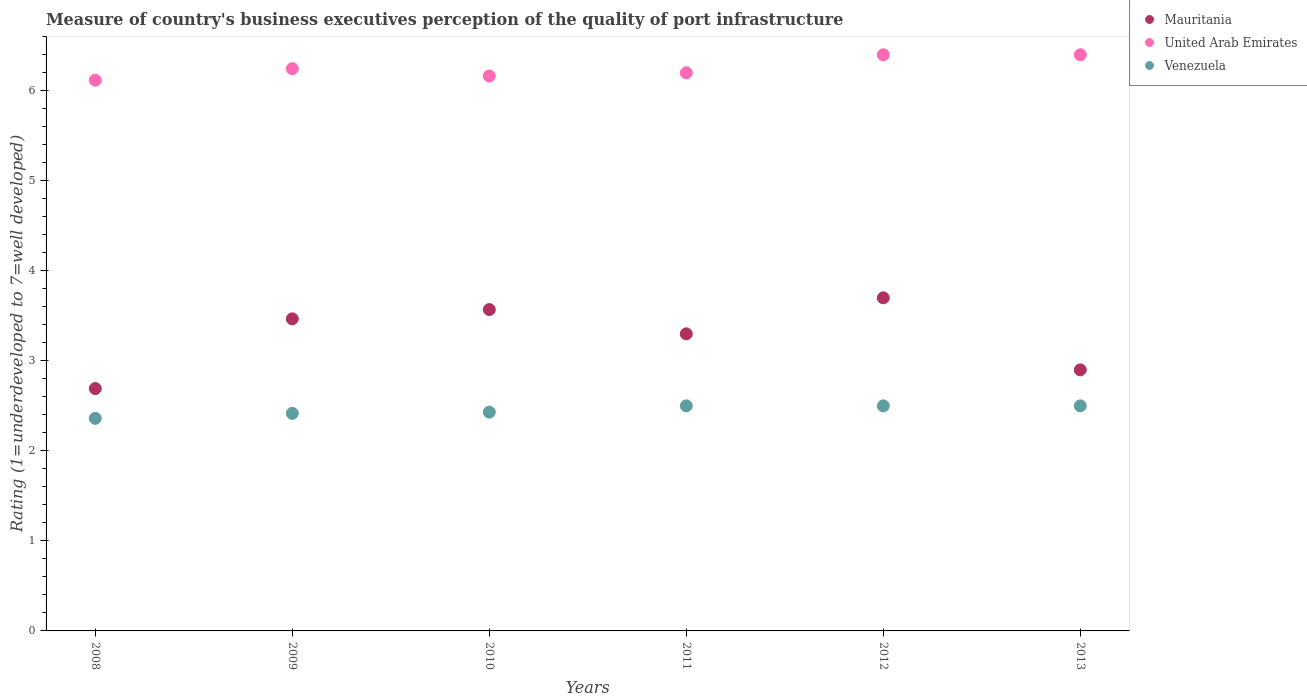Is the number of dotlines equal to the number of legend labels?
Provide a short and direct response. Yes. Across all years, what is the minimum ratings of the quality of port infrastructure in United Arab Emirates?
Keep it short and to the point. 6.12. In which year was the ratings of the quality of port infrastructure in Venezuela maximum?
Your answer should be compact. 2011. What is the total ratings of the quality of port infrastructure in Mauritania in the graph?
Give a very brief answer. 19.63. What is the difference between the ratings of the quality of port infrastructure in Mauritania in 2008 and that in 2012?
Ensure brevity in your answer.  -1.01. What is the difference between the ratings of the quality of port infrastructure in Venezuela in 2011 and the ratings of the quality of port infrastructure in Mauritania in 2012?
Give a very brief answer. -1.2. What is the average ratings of the quality of port infrastructure in Venezuela per year?
Your answer should be compact. 2.45. In how many years, is the ratings of the quality of port infrastructure in United Arab Emirates greater than 4.8?
Make the answer very short. 6. What is the ratio of the ratings of the quality of port infrastructure in United Arab Emirates in 2008 to that in 2009?
Your answer should be compact. 0.98. Is the difference between the ratings of the quality of port infrastructure in Mauritania in 2008 and 2013 greater than the difference between the ratings of the quality of port infrastructure in United Arab Emirates in 2008 and 2013?
Your response must be concise. Yes. What is the difference between the highest and the second highest ratings of the quality of port infrastructure in Mauritania?
Your answer should be compact. 0.13. What is the difference between the highest and the lowest ratings of the quality of port infrastructure in United Arab Emirates?
Offer a very short reply. 0.28. Is the sum of the ratings of the quality of port infrastructure in Mauritania in 2010 and 2011 greater than the maximum ratings of the quality of port infrastructure in United Arab Emirates across all years?
Ensure brevity in your answer.  Yes. Does the ratings of the quality of port infrastructure in Mauritania monotonically increase over the years?
Ensure brevity in your answer.  No. Is the ratings of the quality of port infrastructure in Mauritania strictly greater than the ratings of the quality of port infrastructure in Venezuela over the years?
Offer a terse response. Yes. How many dotlines are there?
Provide a succinct answer. 3. What is the difference between two consecutive major ticks on the Y-axis?
Your response must be concise. 1. Are the values on the major ticks of Y-axis written in scientific E-notation?
Provide a short and direct response. No. Does the graph contain grids?
Your answer should be very brief. No. Where does the legend appear in the graph?
Give a very brief answer. Top right. What is the title of the graph?
Offer a terse response. Measure of country's business executives perception of the quality of port infrastructure. What is the label or title of the Y-axis?
Make the answer very short. Rating (1=underdeveloped to 7=well developed). What is the Rating (1=underdeveloped to 7=well developed) in Mauritania in 2008?
Make the answer very short. 2.69. What is the Rating (1=underdeveloped to 7=well developed) in United Arab Emirates in 2008?
Keep it short and to the point. 6.12. What is the Rating (1=underdeveloped to 7=well developed) of Venezuela in 2008?
Make the answer very short. 2.36. What is the Rating (1=underdeveloped to 7=well developed) of Mauritania in 2009?
Your response must be concise. 3.47. What is the Rating (1=underdeveloped to 7=well developed) of United Arab Emirates in 2009?
Your answer should be compact. 6.24. What is the Rating (1=underdeveloped to 7=well developed) in Venezuela in 2009?
Offer a terse response. 2.42. What is the Rating (1=underdeveloped to 7=well developed) of Mauritania in 2010?
Your response must be concise. 3.57. What is the Rating (1=underdeveloped to 7=well developed) in United Arab Emirates in 2010?
Keep it short and to the point. 6.16. What is the Rating (1=underdeveloped to 7=well developed) in Venezuela in 2010?
Your response must be concise. 2.43. What is the Rating (1=underdeveloped to 7=well developed) of Mauritania in 2011?
Your answer should be very brief. 3.3. Across all years, what is the maximum Rating (1=underdeveloped to 7=well developed) in Mauritania?
Your answer should be very brief. 3.7. Across all years, what is the maximum Rating (1=underdeveloped to 7=well developed) in United Arab Emirates?
Keep it short and to the point. 6.4. Across all years, what is the minimum Rating (1=underdeveloped to 7=well developed) in Mauritania?
Provide a succinct answer. 2.69. Across all years, what is the minimum Rating (1=underdeveloped to 7=well developed) of United Arab Emirates?
Offer a terse response. 6.12. Across all years, what is the minimum Rating (1=underdeveloped to 7=well developed) of Venezuela?
Your response must be concise. 2.36. What is the total Rating (1=underdeveloped to 7=well developed) in Mauritania in the graph?
Ensure brevity in your answer.  19.63. What is the total Rating (1=underdeveloped to 7=well developed) in United Arab Emirates in the graph?
Your answer should be very brief. 37.53. What is the total Rating (1=underdeveloped to 7=well developed) in Venezuela in the graph?
Provide a short and direct response. 14.71. What is the difference between the Rating (1=underdeveloped to 7=well developed) of Mauritania in 2008 and that in 2009?
Keep it short and to the point. -0.77. What is the difference between the Rating (1=underdeveloped to 7=well developed) of United Arab Emirates in 2008 and that in 2009?
Offer a very short reply. -0.13. What is the difference between the Rating (1=underdeveloped to 7=well developed) in Venezuela in 2008 and that in 2009?
Your response must be concise. -0.06. What is the difference between the Rating (1=underdeveloped to 7=well developed) of Mauritania in 2008 and that in 2010?
Your answer should be very brief. -0.88. What is the difference between the Rating (1=underdeveloped to 7=well developed) of United Arab Emirates in 2008 and that in 2010?
Offer a terse response. -0.05. What is the difference between the Rating (1=underdeveloped to 7=well developed) in Venezuela in 2008 and that in 2010?
Provide a short and direct response. -0.07. What is the difference between the Rating (1=underdeveloped to 7=well developed) in Mauritania in 2008 and that in 2011?
Your response must be concise. -0.61. What is the difference between the Rating (1=underdeveloped to 7=well developed) in United Arab Emirates in 2008 and that in 2011?
Your answer should be compact. -0.08. What is the difference between the Rating (1=underdeveloped to 7=well developed) in Venezuela in 2008 and that in 2011?
Your response must be concise. -0.14. What is the difference between the Rating (1=underdeveloped to 7=well developed) of Mauritania in 2008 and that in 2012?
Ensure brevity in your answer.  -1.01. What is the difference between the Rating (1=underdeveloped to 7=well developed) in United Arab Emirates in 2008 and that in 2012?
Make the answer very short. -0.28. What is the difference between the Rating (1=underdeveloped to 7=well developed) of Venezuela in 2008 and that in 2012?
Make the answer very short. -0.14. What is the difference between the Rating (1=underdeveloped to 7=well developed) of Mauritania in 2008 and that in 2013?
Your answer should be compact. -0.21. What is the difference between the Rating (1=underdeveloped to 7=well developed) of United Arab Emirates in 2008 and that in 2013?
Keep it short and to the point. -0.28. What is the difference between the Rating (1=underdeveloped to 7=well developed) in Venezuela in 2008 and that in 2013?
Provide a succinct answer. -0.14. What is the difference between the Rating (1=underdeveloped to 7=well developed) of Mauritania in 2009 and that in 2010?
Provide a short and direct response. -0.1. What is the difference between the Rating (1=underdeveloped to 7=well developed) in United Arab Emirates in 2009 and that in 2010?
Your response must be concise. 0.08. What is the difference between the Rating (1=underdeveloped to 7=well developed) in Venezuela in 2009 and that in 2010?
Your response must be concise. -0.01. What is the difference between the Rating (1=underdeveloped to 7=well developed) in Mauritania in 2009 and that in 2011?
Offer a very short reply. 0.17. What is the difference between the Rating (1=underdeveloped to 7=well developed) in United Arab Emirates in 2009 and that in 2011?
Your answer should be very brief. 0.04. What is the difference between the Rating (1=underdeveloped to 7=well developed) of Venezuela in 2009 and that in 2011?
Make the answer very short. -0.08. What is the difference between the Rating (1=underdeveloped to 7=well developed) in Mauritania in 2009 and that in 2012?
Your answer should be very brief. -0.23. What is the difference between the Rating (1=underdeveloped to 7=well developed) in United Arab Emirates in 2009 and that in 2012?
Provide a succinct answer. -0.15. What is the difference between the Rating (1=underdeveloped to 7=well developed) in Venezuela in 2009 and that in 2012?
Your response must be concise. -0.08. What is the difference between the Rating (1=underdeveloped to 7=well developed) of Mauritania in 2009 and that in 2013?
Provide a short and direct response. 0.57. What is the difference between the Rating (1=underdeveloped to 7=well developed) of United Arab Emirates in 2009 and that in 2013?
Your answer should be compact. -0.15. What is the difference between the Rating (1=underdeveloped to 7=well developed) of Venezuela in 2009 and that in 2013?
Make the answer very short. -0.08. What is the difference between the Rating (1=underdeveloped to 7=well developed) in Mauritania in 2010 and that in 2011?
Your response must be concise. 0.27. What is the difference between the Rating (1=underdeveloped to 7=well developed) in United Arab Emirates in 2010 and that in 2011?
Offer a terse response. -0.04. What is the difference between the Rating (1=underdeveloped to 7=well developed) in Venezuela in 2010 and that in 2011?
Keep it short and to the point. -0.07. What is the difference between the Rating (1=underdeveloped to 7=well developed) in Mauritania in 2010 and that in 2012?
Make the answer very short. -0.13. What is the difference between the Rating (1=underdeveloped to 7=well developed) in United Arab Emirates in 2010 and that in 2012?
Give a very brief answer. -0.24. What is the difference between the Rating (1=underdeveloped to 7=well developed) of Venezuela in 2010 and that in 2012?
Keep it short and to the point. -0.07. What is the difference between the Rating (1=underdeveloped to 7=well developed) in Mauritania in 2010 and that in 2013?
Provide a succinct answer. 0.67. What is the difference between the Rating (1=underdeveloped to 7=well developed) in United Arab Emirates in 2010 and that in 2013?
Make the answer very short. -0.24. What is the difference between the Rating (1=underdeveloped to 7=well developed) of Venezuela in 2010 and that in 2013?
Your answer should be compact. -0.07. What is the difference between the Rating (1=underdeveloped to 7=well developed) of Mauritania in 2011 and that in 2012?
Your answer should be compact. -0.4. What is the difference between the Rating (1=underdeveloped to 7=well developed) of United Arab Emirates in 2011 and that in 2013?
Offer a very short reply. -0.2. What is the difference between the Rating (1=underdeveloped to 7=well developed) of Mauritania in 2012 and that in 2013?
Your response must be concise. 0.8. What is the difference between the Rating (1=underdeveloped to 7=well developed) of Venezuela in 2012 and that in 2013?
Your answer should be compact. 0. What is the difference between the Rating (1=underdeveloped to 7=well developed) in Mauritania in 2008 and the Rating (1=underdeveloped to 7=well developed) in United Arab Emirates in 2009?
Provide a succinct answer. -3.55. What is the difference between the Rating (1=underdeveloped to 7=well developed) in Mauritania in 2008 and the Rating (1=underdeveloped to 7=well developed) in Venezuela in 2009?
Make the answer very short. 0.28. What is the difference between the Rating (1=underdeveloped to 7=well developed) in United Arab Emirates in 2008 and the Rating (1=underdeveloped to 7=well developed) in Venezuela in 2009?
Offer a very short reply. 3.7. What is the difference between the Rating (1=underdeveloped to 7=well developed) of Mauritania in 2008 and the Rating (1=underdeveloped to 7=well developed) of United Arab Emirates in 2010?
Keep it short and to the point. -3.47. What is the difference between the Rating (1=underdeveloped to 7=well developed) of Mauritania in 2008 and the Rating (1=underdeveloped to 7=well developed) of Venezuela in 2010?
Offer a very short reply. 0.26. What is the difference between the Rating (1=underdeveloped to 7=well developed) of United Arab Emirates in 2008 and the Rating (1=underdeveloped to 7=well developed) of Venezuela in 2010?
Offer a terse response. 3.69. What is the difference between the Rating (1=underdeveloped to 7=well developed) in Mauritania in 2008 and the Rating (1=underdeveloped to 7=well developed) in United Arab Emirates in 2011?
Your answer should be compact. -3.51. What is the difference between the Rating (1=underdeveloped to 7=well developed) in Mauritania in 2008 and the Rating (1=underdeveloped to 7=well developed) in Venezuela in 2011?
Provide a short and direct response. 0.19. What is the difference between the Rating (1=underdeveloped to 7=well developed) of United Arab Emirates in 2008 and the Rating (1=underdeveloped to 7=well developed) of Venezuela in 2011?
Give a very brief answer. 3.62. What is the difference between the Rating (1=underdeveloped to 7=well developed) of Mauritania in 2008 and the Rating (1=underdeveloped to 7=well developed) of United Arab Emirates in 2012?
Your answer should be very brief. -3.71. What is the difference between the Rating (1=underdeveloped to 7=well developed) in Mauritania in 2008 and the Rating (1=underdeveloped to 7=well developed) in Venezuela in 2012?
Keep it short and to the point. 0.19. What is the difference between the Rating (1=underdeveloped to 7=well developed) of United Arab Emirates in 2008 and the Rating (1=underdeveloped to 7=well developed) of Venezuela in 2012?
Your answer should be compact. 3.62. What is the difference between the Rating (1=underdeveloped to 7=well developed) of Mauritania in 2008 and the Rating (1=underdeveloped to 7=well developed) of United Arab Emirates in 2013?
Provide a succinct answer. -3.71. What is the difference between the Rating (1=underdeveloped to 7=well developed) of Mauritania in 2008 and the Rating (1=underdeveloped to 7=well developed) of Venezuela in 2013?
Offer a very short reply. 0.19. What is the difference between the Rating (1=underdeveloped to 7=well developed) of United Arab Emirates in 2008 and the Rating (1=underdeveloped to 7=well developed) of Venezuela in 2013?
Provide a succinct answer. 3.62. What is the difference between the Rating (1=underdeveloped to 7=well developed) of Mauritania in 2009 and the Rating (1=underdeveloped to 7=well developed) of United Arab Emirates in 2010?
Make the answer very short. -2.7. What is the difference between the Rating (1=underdeveloped to 7=well developed) of Mauritania in 2009 and the Rating (1=underdeveloped to 7=well developed) of Venezuela in 2010?
Your response must be concise. 1.04. What is the difference between the Rating (1=underdeveloped to 7=well developed) of United Arab Emirates in 2009 and the Rating (1=underdeveloped to 7=well developed) of Venezuela in 2010?
Offer a terse response. 3.81. What is the difference between the Rating (1=underdeveloped to 7=well developed) in Mauritania in 2009 and the Rating (1=underdeveloped to 7=well developed) in United Arab Emirates in 2011?
Provide a succinct answer. -2.73. What is the difference between the Rating (1=underdeveloped to 7=well developed) of Mauritania in 2009 and the Rating (1=underdeveloped to 7=well developed) of Venezuela in 2011?
Your response must be concise. 0.97. What is the difference between the Rating (1=underdeveloped to 7=well developed) of United Arab Emirates in 2009 and the Rating (1=underdeveloped to 7=well developed) of Venezuela in 2011?
Offer a very short reply. 3.75. What is the difference between the Rating (1=underdeveloped to 7=well developed) in Mauritania in 2009 and the Rating (1=underdeveloped to 7=well developed) in United Arab Emirates in 2012?
Make the answer very short. -2.93. What is the difference between the Rating (1=underdeveloped to 7=well developed) of Mauritania in 2009 and the Rating (1=underdeveloped to 7=well developed) of Venezuela in 2012?
Make the answer very short. 0.97. What is the difference between the Rating (1=underdeveloped to 7=well developed) in United Arab Emirates in 2009 and the Rating (1=underdeveloped to 7=well developed) in Venezuela in 2012?
Offer a very short reply. 3.75. What is the difference between the Rating (1=underdeveloped to 7=well developed) in Mauritania in 2009 and the Rating (1=underdeveloped to 7=well developed) in United Arab Emirates in 2013?
Your answer should be compact. -2.93. What is the difference between the Rating (1=underdeveloped to 7=well developed) in Mauritania in 2009 and the Rating (1=underdeveloped to 7=well developed) in Venezuela in 2013?
Your answer should be compact. 0.97. What is the difference between the Rating (1=underdeveloped to 7=well developed) of United Arab Emirates in 2009 and the Rating (1=underdeveloped to 7=well developed) of Venezuela in 2013?
Provide a short and direct response. 3.75. What is the difference between the Rating (1=underdeveloped to 7=well developed) in Mauritania in 2010 and the Rating (1=underdeveloped to 7=well developed) in United Arab Emirates in 2011?
Ensure brevity in your answer.  -2.63. What is the difference between the Rating (1=underdeveloped to 7=well developed) in Mauritania in 2010 and the Rating (1=underdeveloped to 7=well developed) in Venezuela in 2011?
Offer a very short reply. 1.07. What is the difference between the Rating (1=underdeveloped to 7=well developed) in United Arab Emirates in 2010 and the Rating (1=underdeveloped to 7=well developed) in Venezuela in 2011?
Provide a short and direct response. 3.66. What is the difference between the Rating (1=underdeveloped to 7=well developed) of Mauritania in 2010 and the Rating (1=underdeveloped to 7=well developed) of United Arab Emirates in 2012?
Make the answer very short. -2.83. What is the difference between the Rating (1=underdeveloped to 7=well developed) in Mauritania in 2010 and the Rating (1=underdeveloped to 7=well developed) in Venezuela in 2012?
Ensure brevity in your answer.  1.07. What is the difference between the Rating (1=underdeveloped to 7=well developed) of United Arab Emirates in 2010 and the Rating (1=underdeveloped to 7=well developed) of Venezuela in 2012?
Your answer should be compact. 3.66. What is the difference between the Rating (1=underdeveloped to 7=well developed) in Mauritania in 2010 and the Rating (1=underdeveloped to 7=well developed) in United Arab Emirates in 2013?
Offer a very short reply. -2.83. What is the difference between the Rating (1=underdeveloped to 7=well developed) in Mauritania in 2010 and the Rating (1=underdeveloped to 7=well developed) in Venezuela in 2013?
Make the answer very short. 1.07. What is the difference between the Rating (1=underdeveloped to 7=well developed) of United Arab Emirates in 2010 and the Rating (1=underdeveloped to 7=well developed) of Venezuela in 2013?
Provide a succinct answer. 3.66. What is the difference between the Rating (1=underdeveloped to 7=well developed) of Mauritania in 2011 and the Rating (1=underdeveloped to 7=well developed) of United Arab Emirates in 2013?
Offer a very short reply. -3.1. What is the difference between the Rating (1=underdeveloped to 7=well developed) of United Arab Emirates in 2011 and the Rating (1=underdeveloped to 7=well developed) of Venezuela in 2013?
Offer a very short reply. 3.7. What is the average Rating (1=underdeveloped to 7=well developed) in Mauritania per year?
Make the answer very short. 3.27. What is the average Rating (1=underdeveloped to 7=well developed) of United Arab Emirates per year?
Make the answer very short. 6.25. What is the average Rating (1=underdeveloped to 7=well developed) in Venezuela per year?
Keep it short and to the point. 2.45. In the year 2008, what is the difference between the Rating (1=underdeveloped to 7=well developed) of Mauritania and Rating (1=underdeveloped to 7=well developed) of United Arab Emirates?
Give a very brief answer. -3.43. In the year 2008, what is the difference between the Rating (1=underdeveloped to 7=well developed) in Mauritania and Rating (1=underdeveloped to 7=well developed) in Venezuela?
Your response must be concise. 0.33. In the year 2008, what is the difference between the Rating (1=underdeveloped to 7=well developed) of United Arab Emirates and Rating (1=underdeveloped to 7=well developed) of Venezuela?
Make the answer very short. 3.76. In the year 2009, what is the difference between the Rating (1=underdeveloped to 7=well developed) of Mauritania and Rating (1=underdeveloped to 7=well developed) of United Arab Emirates?
Your response must be concise. -2.78. In the year 2009, what is the difference between the Rating (1=underdeveloped to 7=well developed) in Mauritania and Rating (1=underdeveloped to 7=well developed) in Venezuela?
Your answer should be very brief. 1.05. In the year 2009, what is the difference between the Rating (1=underdeveloped to 7=well developed) in United Arab Emirates and Rating (1=underdeveloped to 7=well developed) in Venezuela?
Keep it short and to the point. 3.83. In the year 2010, what is the difference between the Rating (1=underdeveloped to 7=well developed) of Mauritania and Rating (1=underdeveloped to 7=well developed) of United Arab Emirates?
Offer a very short reply. -2.59. In the year 2010, what is the difference between the Rating (1=underdeveloped to 7=well developed) in Mauritania and Rating (1=underdeveloped to 7=well developed) in Venezuela?
Keep it short and to the point. 1.14. In the year 2010, what is the difference between the Rating (1=underdeveloped to 7=well developed) in United Arab Emirates and Rating (1=underdeveloped to 7=well developed) in Venezuela?
Keep it short and to the point. 3.73. In the year 2011, what is the difference between the Rating (1=underdeveloped to 7=well developed) of Mauritania and Rating (1=underdeveloped to 7=well developed) of United Arab Emirates?
Make the answer very short. -2.9. In the year 2012, what is the difference between the Rating (1=underdeveloped to 7=well developed) in Mauritania and Rating (1=underdeveloped to 7=well developed) in United Arab Emirates?
Your answer should be compact. -2.7. In the year 2012, what is the difference between the Rating (1=underdeveloped to 7=well developed) in United Arab Emirates and Rating (1=underdeveloped to 7=well developed) in Venezuela?
Keep it short and to the point. 3.9. In the year 2013, what is the difference between the Rating (1=underdeveloped to 7=well developed) of Mauritania and Rating (1=underdeveloped to 7=well developed) of United Arab Emirates?
Provide a succinct answer. -3.5. In the year 2013, what is the difference between the Rating (1=underdeveloped to 7=well developed) in Mauritania and Rating (1=underdeveloped to 7=well developed) in Venezuela?
Offer a terse response. 0.4. In the year 2013, what is the difference between the Rating (1=underdeveloped to 7=well developed) of United Arab Emirates and Rating (1=underdeveloped to 7=well developed) of Venezuela?
Keep it short and to the point. 3.9. What is the ratio of the Rating (1=underdeveloped to 7=well developed) in Mauritania in 2008 to that in 2009?
Provide a succinct answer. 0.78. What is the ratio of the Rating (1=underdeveloped to 7=well developed) of United Arab Emirates in 2008 to that in 2009?
Your answer should be compact. 0.98. What is the ratio of the Rating (1=underdeveloped to 7=well developed) of Venezuela in 2008 to that in 2009?
Offer a very short reply. 0.98. What is the ratio of the Rating (1=underdeveloped to 7=well developed) of Mauritania in 2008 to that in 2010?
Ensure brevity in your answer.  0.75. What is the ratio of the Rating (1=underdeveloped to 7=well developed) in United Arab Emirates in 2008 to that in 2010?
Ensure brevity in your answer.  0.99. What is the ratio of the Rating (1=underdeveloped to 7=well developed) in Venezuela in 2008 to that in 2010?
Keep it short and to the point. 0.97. What is the ratio of the Rating (1=underdeveloped to 7=well developed) in Mauritania in 2008 to that in 2011?
Keep it short and to the point. 0.82. What is the ratio of the Rating (1=underdeveloped to 7=well developed) of United Arab Emirates in 2008 to that in 2011?
Your response must be concise. 0.99. What is the ratio of the Rating (1=underdeveloped to 7=well developed) of Venezuela in 2008 to that in 2011?
Offer a terse response. 0.94. What is the ratio of the Rating (1=underdeveloped to 7=well developed) of Mauritania in 2008 to that in 2012?
Your answer should be compact. 0.73. What is the ratio of the Rating (1=underdeveloped to 7=well developed) of United Arab Emirates in 2008 to that in 2012?
Ensure brevity in your answer.  0.96. What is the ratio of the Rating (1=underdeveloped to 7=well developed) in Venezuela in 2008 to that in 2012?
Offer a very short reply. 0.94. What is the ratio of the Rating (1=underdeveloped to 7=well developed) of Mauritania in 2008 to that in 2013?
Provide a short and direct response. 0.93. What is the ratio of the Rating (1=underdeveloped to 7=well developed) of United Arab Emirates in 2008 to that in 2013?
Provide a succinct answer. 0.96. What is the ratio of the Rating (1=underdeveloped to 7=well developed) in Mauritania in 2009 to that in 2010?
Ensure brevity in your answer.  0.97. What is the ratio of the Rating (1=underdeveloped to 7=well developed) of United Arab Emirates in 2009 to that in 2010?
Offer a very short reply. 1.01. What is the ratio of the Rating (1=underdeveloped to 7=well developed) of Venezuela in 2009 to that in 2010?
Your response must be concise. 0.99. What is the ratio of the Rating (1=underdeveloped to 7=well developed) of Mauritania in 2009 to that in 2011?
Your answer should be very brief. 1.05. What is the ratio of the Rating (1=underdeveloped to 7=well developed) in United Arab Emirates in 2009 to that in 2011?
Provide a succinct answer. 1.01. What is the ratio of the Rating (1=underdeveloped to 7=well developed) of Venezuela in 2009 to that in 2011?
Provide a short and direct response. 0.97. What is the ratio of the Rating (1=underdeveloped to 7=well developed) of Mauritania in 2009 to that in 2012?
Offer a terse response. 0.94. What is the ratio of the Rating (1=underdeveloped to 7=well developed) in United Arab Emirates in 2009 to that in 2012?
Offer a very short reply. 0.98. What is the ratio of the Rating (1=underdeveloped to 7=well developed) in Venezuela in 2009 to that in 2012?
Ensure brevity in your answer.  0.97. What is the ratio of the Rating (1=underdeveloped to 7=well developed) in Mauritania in 2009 to that in 2013?
Offer a terse response. 1.2. What is the ratio of the Rating (1=underdeveloped to 7=well developed) in United Arab Emirates in 2009 to that in 2013?
Offer a terse response. 0.98. What is the ratio of the Rating (1=underdeveloped to 7=well developed) in Venezuela in 2009 to that in 2013?
Your answer should be very brief. 0.97. What is the ratio of the Rating (1=underdeveloped to 7=well developed) in Mauritania in 2010 to that in 2011?
Make the answer very short. 1.08. What is the ratio of the Rating (1=underdeveloped to 7=well developed) in United Arab Emirates in 2010 to that in 2011?
Offer a terse response. 0.99. What is the ratio of the Rating (1=underdeveloped to 7=well developed) in Mauritania in 2010 to that in 2012?
Give a very brief answer. 0.96. What is the ratio of the Rating (1=underdeveloped to 7=well developed) of United Arab Emirates in 2010 to that in 2012?
Provide a short and direct response. 0.96. What is the ratio of the Rating (1=underdeveloped to 7=well developed) of Mauritania in 2010 to that in 2013?
Keep it short and to the point. 1.23. What is the ratio of the Rating (1=underdeveloped to 7=well developed) in United Arab Emirates in 2010 to that in 2013?
Keep it short and to the point. 0.96. What is the ratio of the Rating (1=underdeveloped to 7=well developed) in Mauritania in 2011 to that in 2012?
Keep it short and to the point. 0.89. What is the ratio of the Rating (1=underdeveloped to 7=well developed) of United Arab Emirates in 2011 to that in 2012?
Give a very brief answer. 0.97. What is the ratio of the Rating (1=underdeveloped to 7=well developed) in Venezuela in 2011 to that in 2012?
Provide a short and direct response. 1. What is the ratio of the Rating (1=underdeveloped to 7=well developed) of Mauritania in 2011 to that in 2013?
Offer a terse response. 1.14. What is the ratio of the Rating (1=underdeveloped to 7=well developed) in United Arab Emirates in 2011 to that in 2013?
Keep it short and to the point. 0.97. What is the ratio of the Rating (1=underdeveloped to 7=well developed) of Venezuela in 2011 to that in 2013?
Keep it short and to the point. 1. What is the ratio of the Rating (1=underdeveloped to 7=well developed) of Mauritania in 2012 to that in 2013?
Provide a succinct answer. 1.28. What is the ratio of the Rating (1=underdeveloped to 7=well developed) in Venezuela in 2012 to that in 2013?
Offer a very short reply. 1. What is the difference between the highest and the second highest Rating (1=underdeveloped to 7=well developed) of Mauritania?
Provide a succinct answer. 0.13. What is the difference between the highest and the lowest Rating (1=underdeveloped to 7=well developed) of Mauritania?
Provide a succinct answer. 1.01. What is the difference between the highest and the lowest Rating (1=underdeveloped to 7=well developed) in United Arab Emirates?
Provide a succinct answer. 0.28. What is the difference between the highest and the lowest Rating (1=underdeveloped to 7=well developed) of Venezuela?
Make the answer very short. 0.14. 